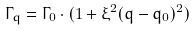<formula> <loc_0><loc_0><loc_500><loc_500>\Gamma _ { q } = \Gamma _ { 0 } \cdot ( 1 + \xi ^ { 2 } ( q - q _ { 0 } ) ^ { 2 } )</formula> 